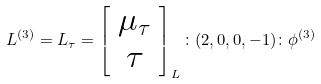<formula> <loc_0><loc_0><loc_500><loc_500>L ^ { ( 3 ) } = L _ { \tau } = \left [ \begin{array} { c } \mu _ { \tau } \\ \tau \end{array} \right ] _ { L } \colon ( 2 , 0 , 0 , - 1 ) \colon \phi ^ { ( 3 ) }</formula> 